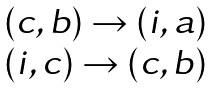Convert formula to latex. <formula><loc_0><loc_0><loc_500><loc_500>\begin{matrix} ( c , b ) \rightarrow ( i , a ) \\ ( i , c ) \rightarrow ( c , b ) \end{matrix}</formula> 